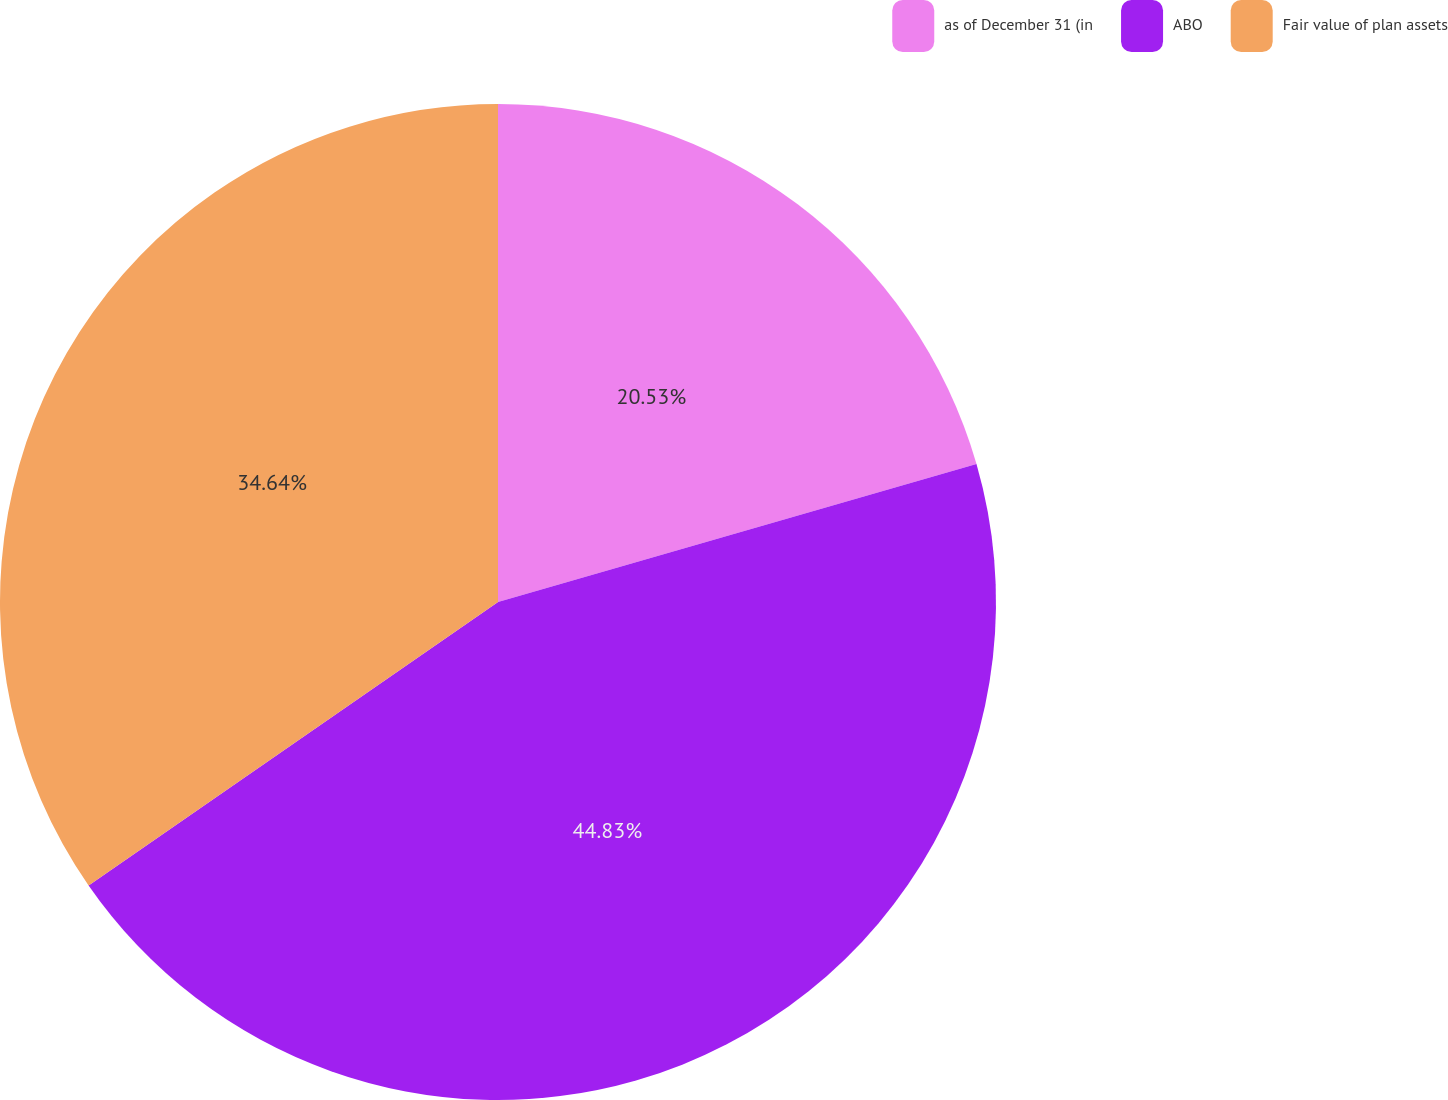<chart> <loc_0><loc_0><loc_500><loc_500><pie_chart><fcel>as of December 31 (in<fcel>ABO<fcel>Fair value of plan assets<nl><fcel>20.53%<fcel>44.83%<fcel>34.64%<nl></chart> 